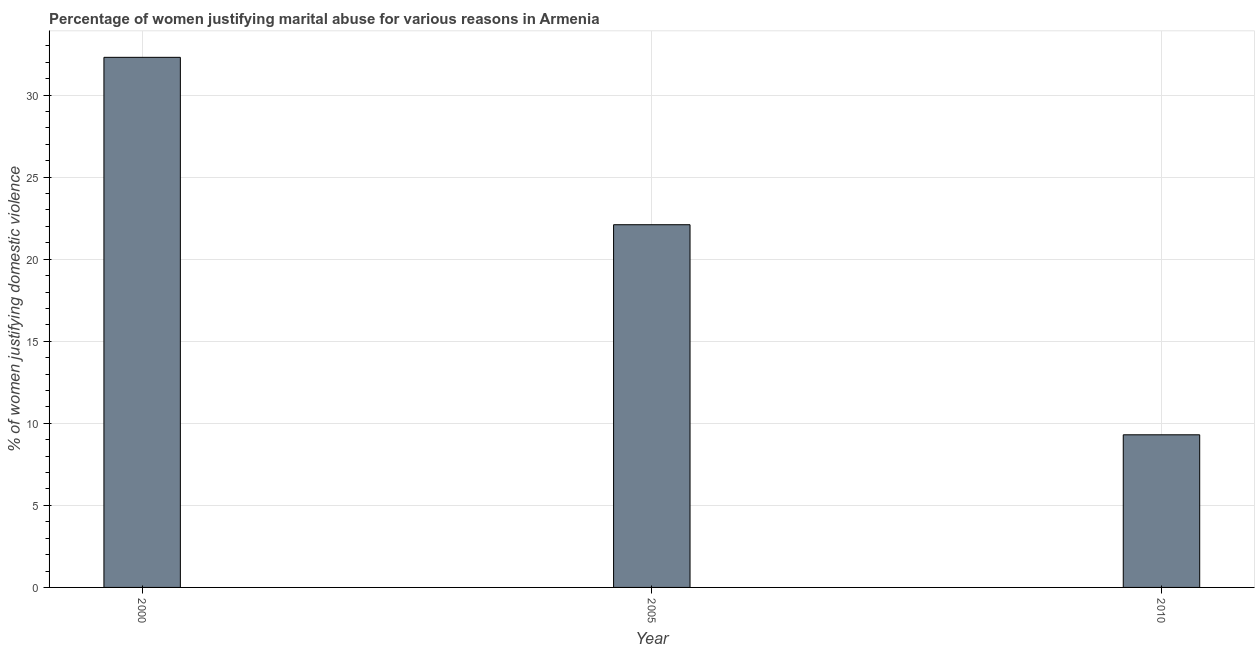Does the graph contain any zero values?
Your answer should be compact. No. What is the title of the graph?
Offer a very short reply. Percentage of women justifying marital abuse for various reasons in Armenia. What is the label or title of the X-axis?
Your response must be concise. Year. What is the label or title of the Y-axis?
Offer a terse response. % of women justifying domestic violence. What is the percentage of women justifying marital abuse in 2000?
Keep it short and to the point. 32.3. Across all years, what is the maximum percentage of women justifying marital abuse?
Offer a very short reply. 32.3. What is the sum of the percentage of women justifying marital abuse?
Provide a succinct answer. 63.7. What is the difference between the percentage of women justifying marital abuse in 2000 and 2005?
Your answer should be compact. 10.2. What is the average percentage of women justifying marital abuse per year?
Your response must be concise. 21.23. What is the median percentage of women justifying marital abuse?
Make the answer very short. 22.1. In how many years, is the percentage of women justifying marital abuse greater than 19 %?
Your response must be concise. 2. What is the ratio of the percentage of women justifying marital abuse in 2000 to that in 2005?
Your answer should be very brief. 1.46. Is the difference between the percentage of women justifying marital abuse in 2000 and 2005 greater than the difference between any two years?
Keep it short and to the point. No. Is the sum of the percentage of women justifying marital abuse in 2005 and 2010 greater than the maximum percentage of women justifying marital abuse across all years?
Keep it short and to the point. No. What is the difference between the highest and the lowest percentage of women justifying marital abuse?
Offer a terse response. 23. In how many years, is the percentage of women justifying marital abuse greater than the average percentage of women justifying marital abuse taken over all years?
Ensure brevity in your answer.  2. Are all the bars in the graph horizontal?
Make the answer very short. No. How many years are there in the graph?
Make the answer very short. 3. What is the difference between two consecutive major ticks on the Y-axis?
Provide a succinct answer. 5. What is the % of women justifying domestic violence of 2000?
Keep it short and to the point. 32.3. What is the % of women justifying domestic violence in 2005?
Provide a succinct answer. 22.1. What is the % of women justifying domestic violence of 2010?
Provide a short and direct response. 9.3. What is the difference between the % of women justifying domestic violence in 2000 and 2005?
Provide a succinct answer. 10.2. What is the difference between the % of women justifying domestic violence in 2000 and 2010?
Provide a succinct answer. 23. What is the ratio of the % of women justifying domestic violence in 2000 to that in 2005?
Make the answer very short. 1.46. What is the ratio of the % of women justifying domestic violence in 2000 to that in 2010?
Keep it short and to the point. 3.47. What is the ratio of the % of women justifying domestic violence in 2005 to that in 2010?
Your answer should be compact. 2.38. 